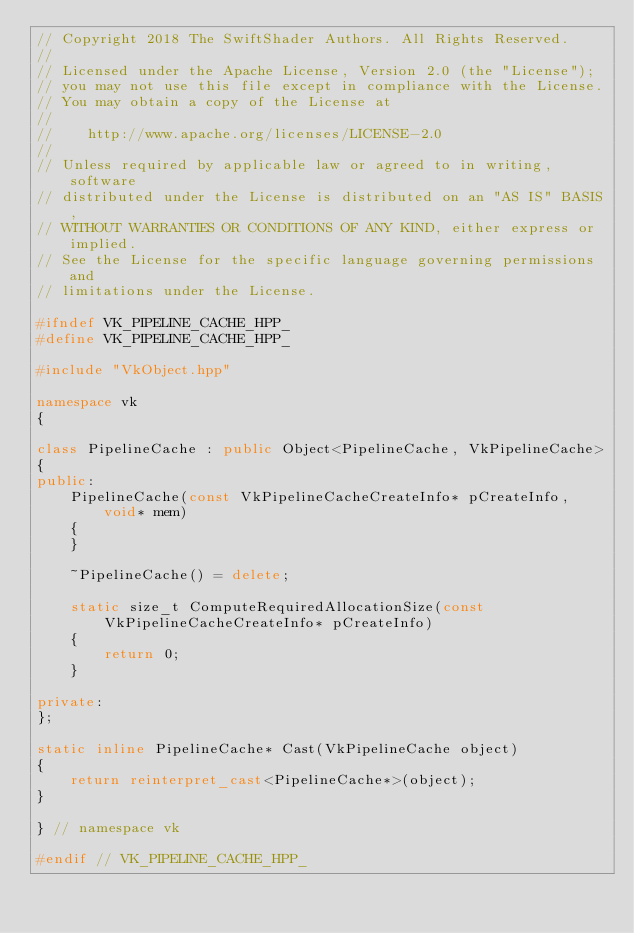Convert code to text. <code><loc_0><loc_0><loc_500><loc_500><_C++_>// Copyright 2018 The SwiftShader Authors. All Rights Reserved.
//
// Licensed under the Apache License, Version 2.0 (the "License");
// you may not use this file except in compliance with the License.
// You may obtain a copy of the License at
//
//    http://www.apache.org/licenses/LICENSE-2.0
//
// Unless required by applicable law or agreed to in writing, software
// distributed under the License is distributed on an "AS IS" BASIS,
// WITHOUT WARRANTIES OR CONDITIONS OF ANY KIND, either express or implied.
// See the License for the specific language governing permissions and
// limitations under the License.

#ifndef VK_PIPELINE_CACHE_HPP_
#define VK_PIPELINE_CACHE_HPP_

#include "VkObject.hpp"

namespace vk
{

class PipelineCache : public Object<PipelineCache, VkPipelineCache>
{
public:
	PipelineCache(const VkPipelineCacheCreateInfo* pCreateInfo, void* mem)
	{
	}

	~PipelineCache() = delete;

	static size_t ComputeRequiredAllocationSize(const VkPipelineCacheCreateInfo* pCreateInfo)
	{
		return 0;
	}

private:
};

static inline PipelineCache* Cast(VkPipelineCache object)
{
	return reinterpret_cast<PipelineCache*>(object);
}

} // namespace vk

#endif // VK_PIPELINE_CACHE_HPP_
</code> 